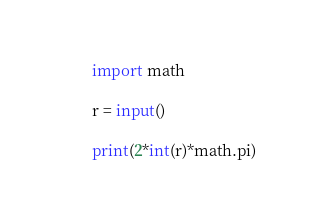<code> <loc_0><loc_0><loc_500><loc_500><_Python_>import math

r = input()

print(2*int(r)*math.pi)</code> 